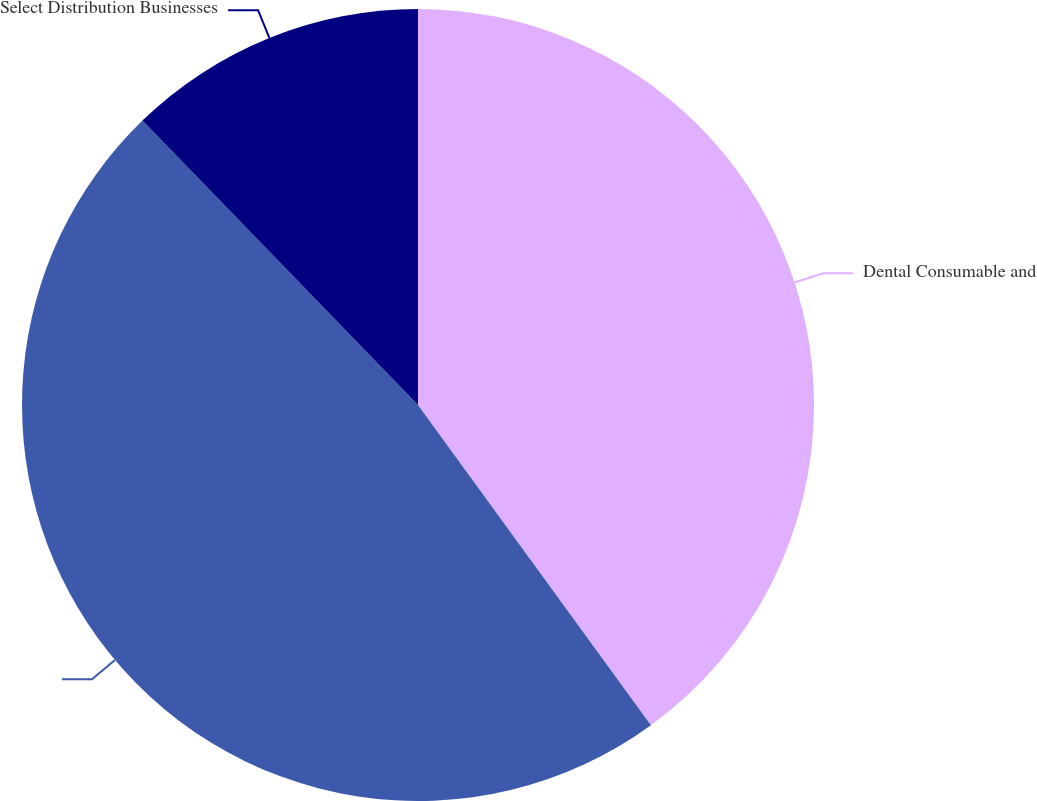Convert chart. <chart><loc_0><loc_0><loc_500><loc_500><pie_chart><fcel>Dental Consumable and<fcel>Unnamed: 1<fcel>Select Distribution Businesses<nl><fcel>39.99%<fcel>47.76%<fcel>12.25%<nl></chart> 